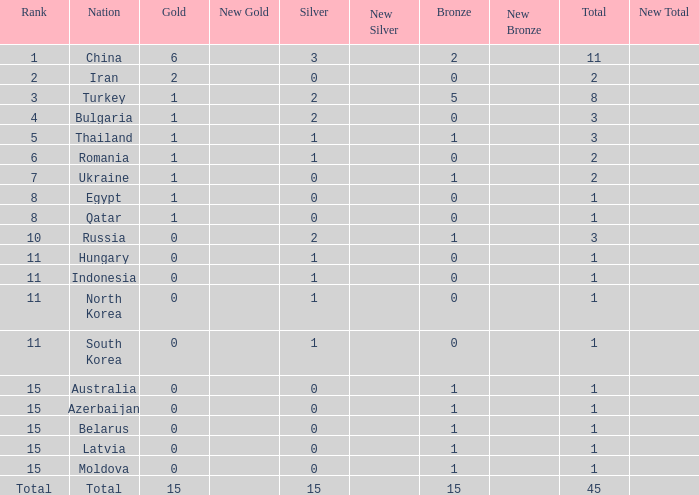What is the highest amount of bronze china, which has more than 1 gold and more than 11 total, has? None. Can you give me this table as a dict? {'header': ['Rank', 'Nation', 'Gold', 'New Gold', 'Silver', 'New Silver', 'Bronze', 'New Bronze', 'Total', 'New Total'], 'rows': [['1', 'China', '6', '', '3', '', '2', '', '11', ''], ['2', 'Iran', '2', '', '0', '', '0', '', '2', ''], ['3', 'Turkey', '1', '', '2', '', '5', '', '8', ''], ['4', 'Bulgaria', '1', '', '2', '', '0', '', '3', ''], ['5', 'Thailand', '1', '', '1', '', '1', '', '3', ''], ['6', 'Romania', '1', '', '1', '', '0', '', '2', ''], ['7', 'Ukraine', '1', '', '0', '', '1', '', '2', ''], ['8', 'Egypt', '1', '', '0', '', '0', '', '1', ''], ['8', 'Qatar', '1', '', '0', '', '0', '', '1', ''], ['10', 'Russia', '0', '', '2', '', '1', '', '3', ''], ['11', 'Hungary', '0', '', '1', '', '0', '', '1', ''], ['11', 'Indonesia', '0', '', '1', '', '0', '', '1', ''], ['11', 'North Korea', '0', '', '1', '', '0', '', '1', ''], ['11', 'South Korea', '0', '', '1', '', '0', '', '1', ''], ['15', 'Australia', '0', '', '0', '', '1', '', '1', ''], ['15', 'Azerbaijan', '0', '', '0', '', '1', '', '1', ''], ['15', 'Belarus', '0', '', '0', '', '1', '', '1', ''], ['15', 'Latvia', '0', '', '0', '', '1', '', '1', ''], ['15', 'Moldova', '0', '', '0', '', '1', '', '1', ''], ['Total', 'Total', '15', '', '15', '', '15', '', '45', '']]} 